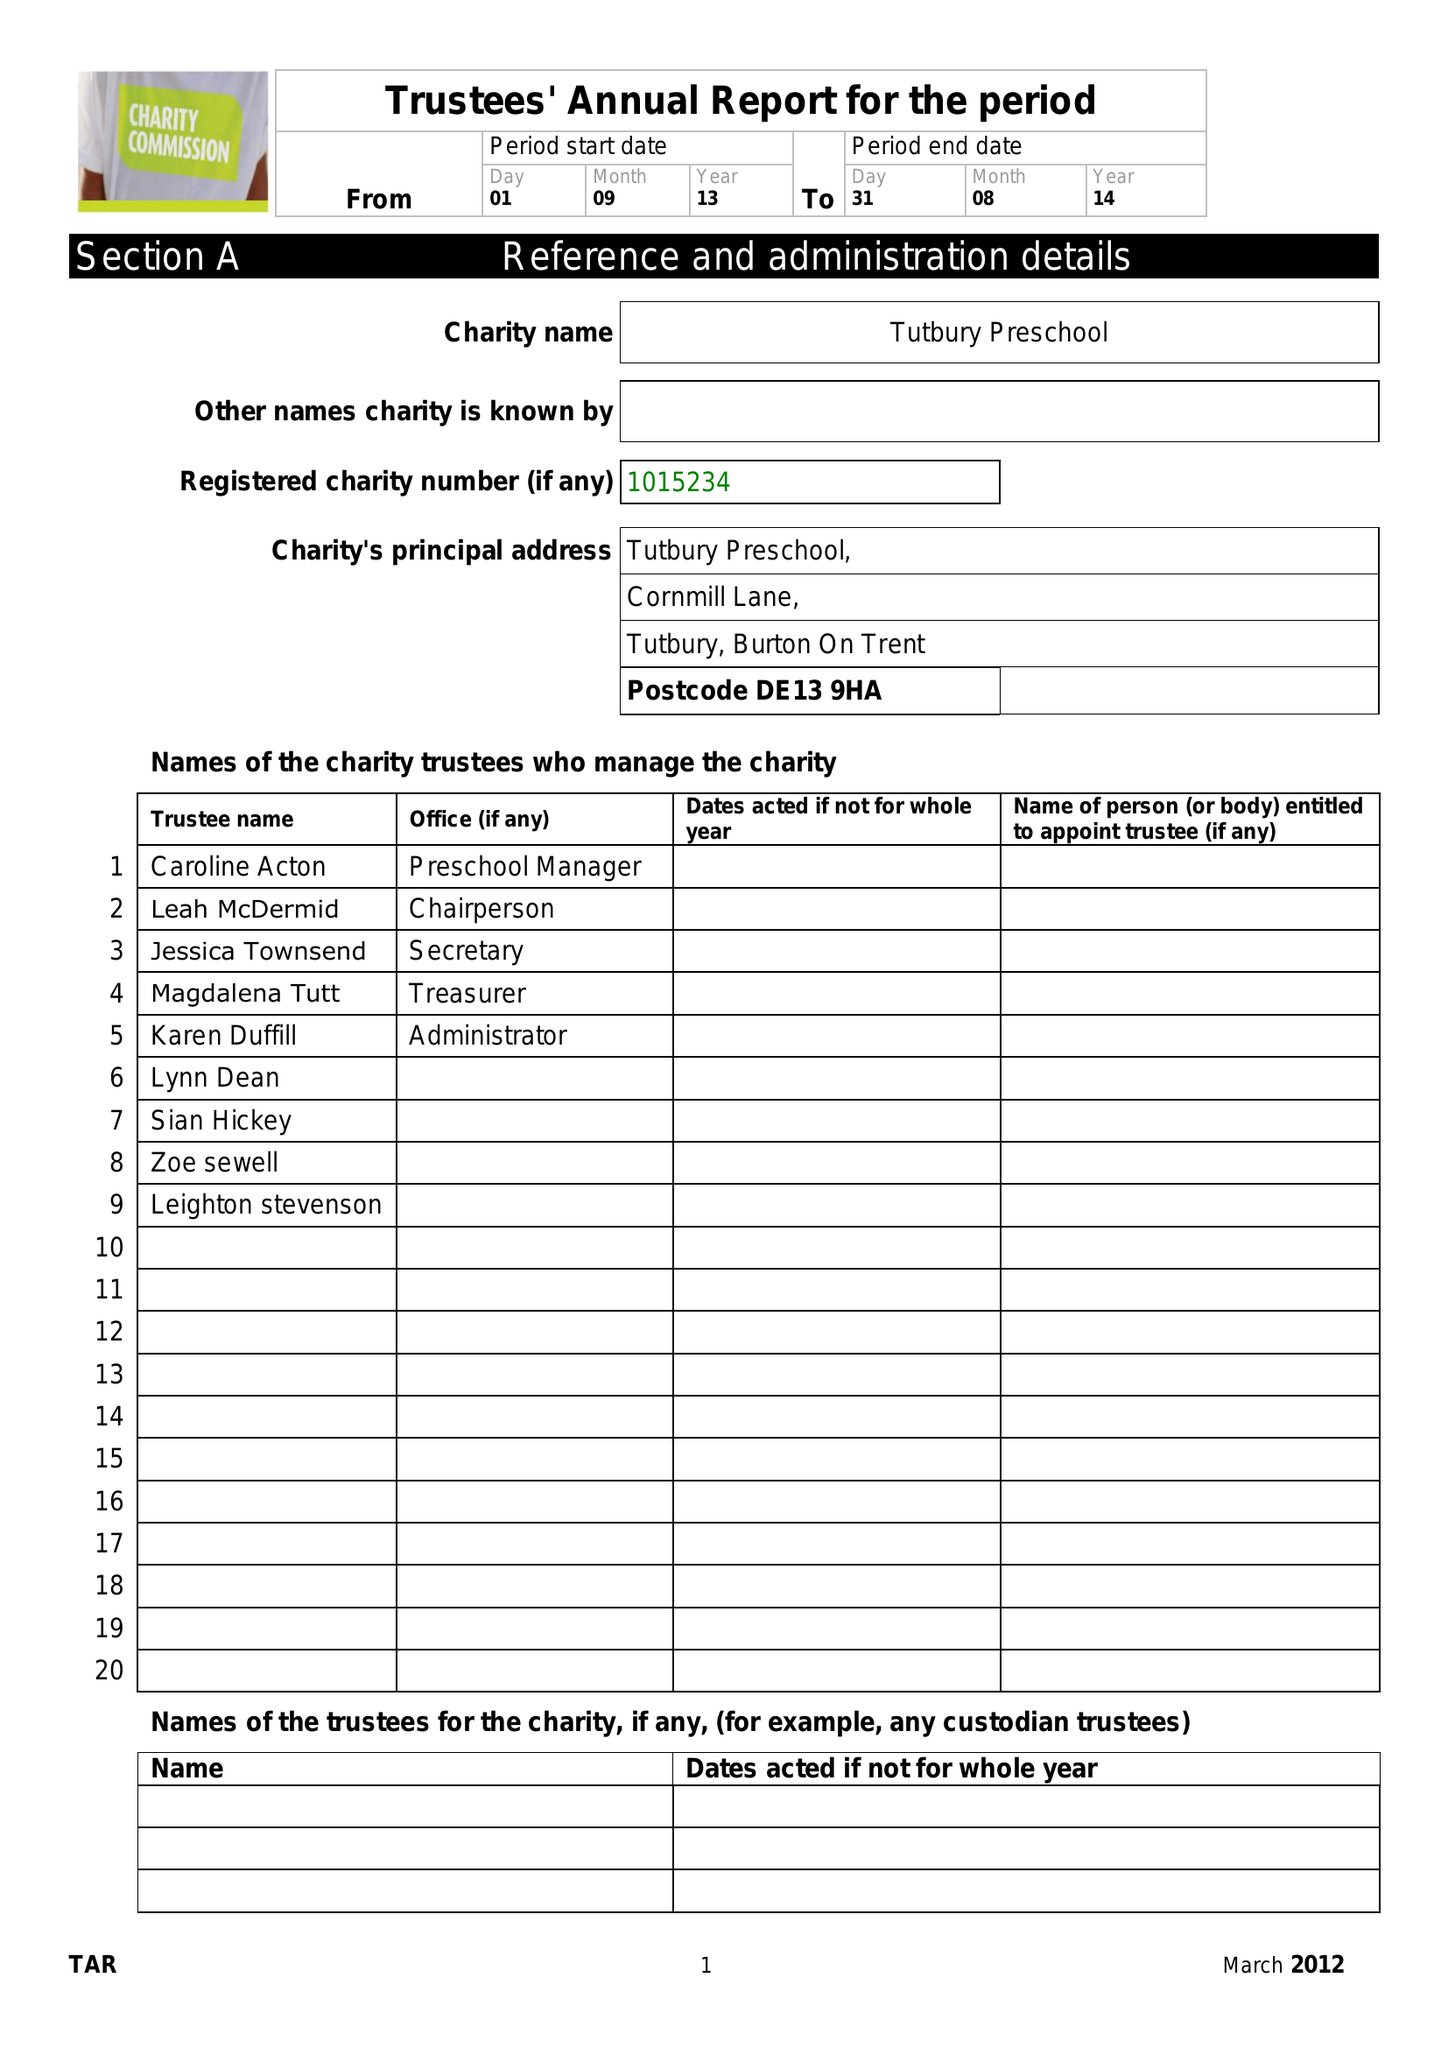What is the value for the charity_name?
Answer the question using a single word or phrase. Tutbury Pre-School Playgroup 